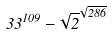<formula> <loc_0><loc_0><loc_500><loc_500>3 3 ^ { 1 0 9 } - \sqrt { 2 } ^ { \sqrt { 2 8 6 } }</formula> 